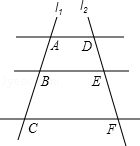Point out the elements visible in the diagram. The image displays two intersecting lines, not three. We have line l1 intersecting with line l2 at points A, B, and C. These points are labeled on line l1, while the corresponding intercepts on line l2 are labeled D, E, and F. It's a simple representation used in geometry to demonstrate concepts such as line intersection and point labeling. 